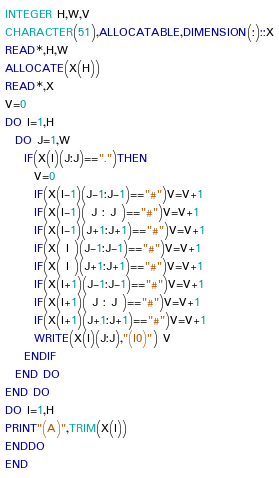<code> <loc_0><loc_0><loc_500><loc_500><_FORTRAN_>INTEGER H,W,V
CHARACTER(51),ALLOCATABLE,DIMENSION(:)::X
READ*,H,W
ALLOCATE(X(H))
READ*,X
V=0
DO I=1,H
  DO J=1,W
    IF(X(I)(J:J)==".")THEN
      V=0
      IF(X(I-1)(J-1:J-1)=="#")V=V+1
      IF(X(I-1)( J : J )=="#")V=V+1
      IF(X(I-1)(J+1:J+1)=="#")V=V+1
      IF(X( I )(J-1:J-1)=="#")V=V+1
      IF(X( I )(J+1:J+1)=="#")V=V+1
      IF(X(I+1)(J-1:J-1)=="#")V=V+1
      IF(X(I+1)( J : J )=="#")V=V+1
      IF(X(I+1)(J+1:J+1)=="#")V=V+1
      WRITE(X(I)(J:J),"(I0)") V
    ENDIF
  END DO
END DO
DO I=1,H
PRINT"(A)",TRIM(X(I))
ENDDO
END</code> 